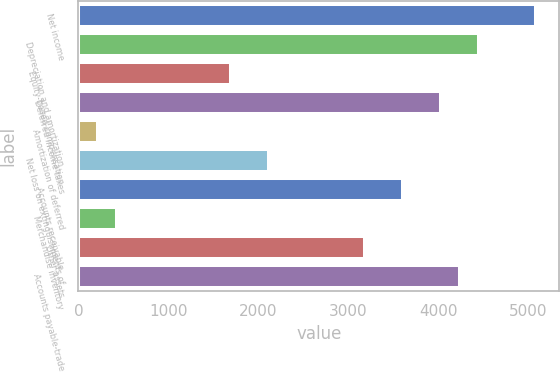<chart> <loc_0><loc_0><loc_500><loc_500><bar_chart><fcel>Net income<fcel>Depreciation and amortization<fcel>Equity-based compensation<fcel>Deferred income taxes<fcel>Amortization of deferred<fcel>Net loss on extinguishments of<fcel>Accounts receivable<fcel>Merchandise inventory<fcel>Other assets<fcel>Accounts payable-trade<nl><fcel>5087.48<fcel>4451.87<fcel>1697.56<fcel>4028.13<fcel>214.47<fcel>2121.3<fcel>3604.39<fcel>426.34<fcel>3180.65<fcel>4240<nl></chart> 